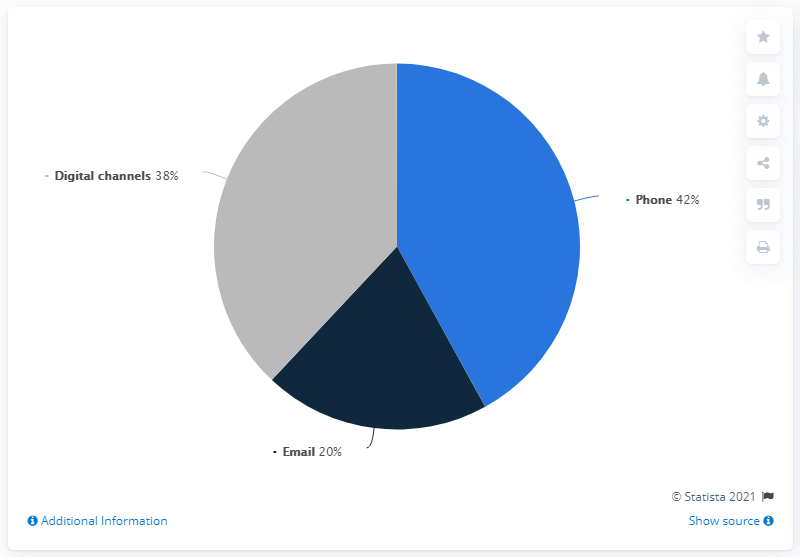Point out several critical features in this image. The median of all communication channels is 1.14 times the average of all communication channels. The color segment with the median value is gray. 